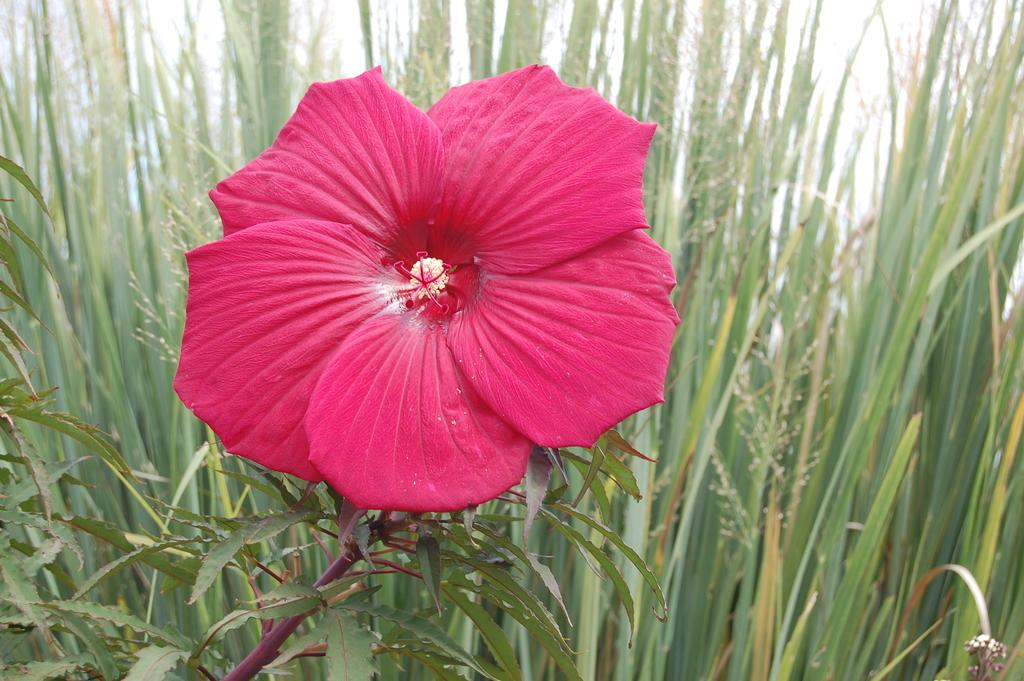What type of flower can be seen in the image? There is a pink color flower in the image. What else is present in the image besides the flower? There are plants in the image. What is visible at the top of the image? The sky is visible at the top of the image. What song is being sung by the dog in the image? There is no dog or song present in the image; it features a pink color flower and plants. 